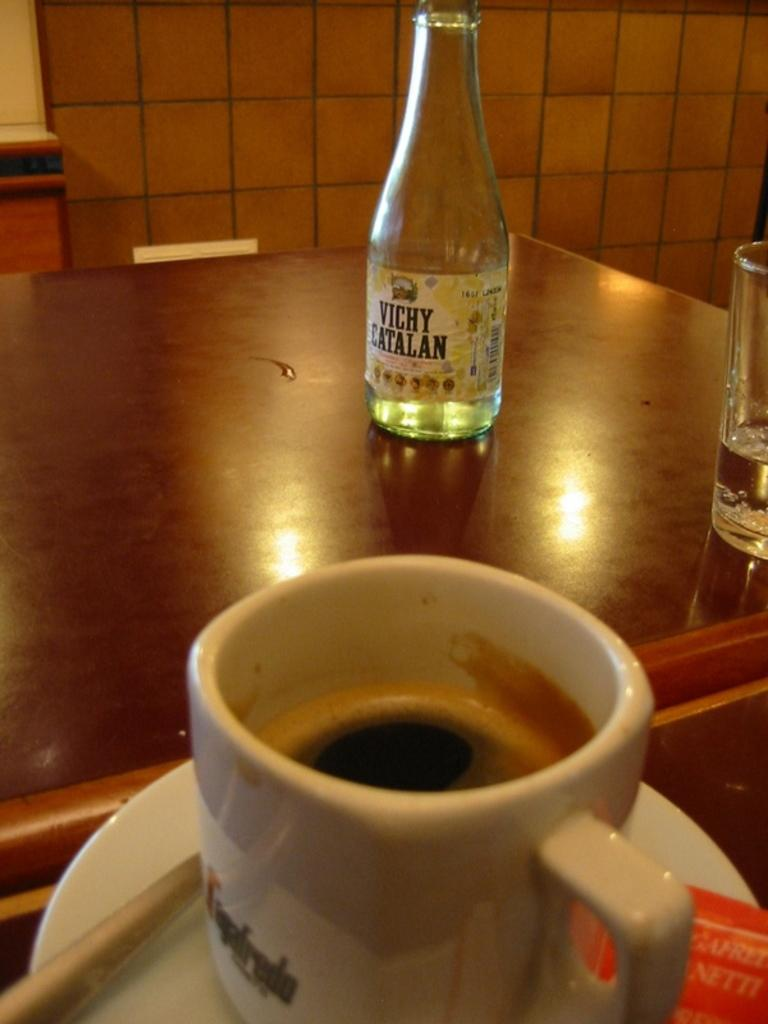Provide a one-sentence caption for the provided image. a cup of coffee, a water glass, and a bottle that says Vichy Catalan on it sitting on a table. 